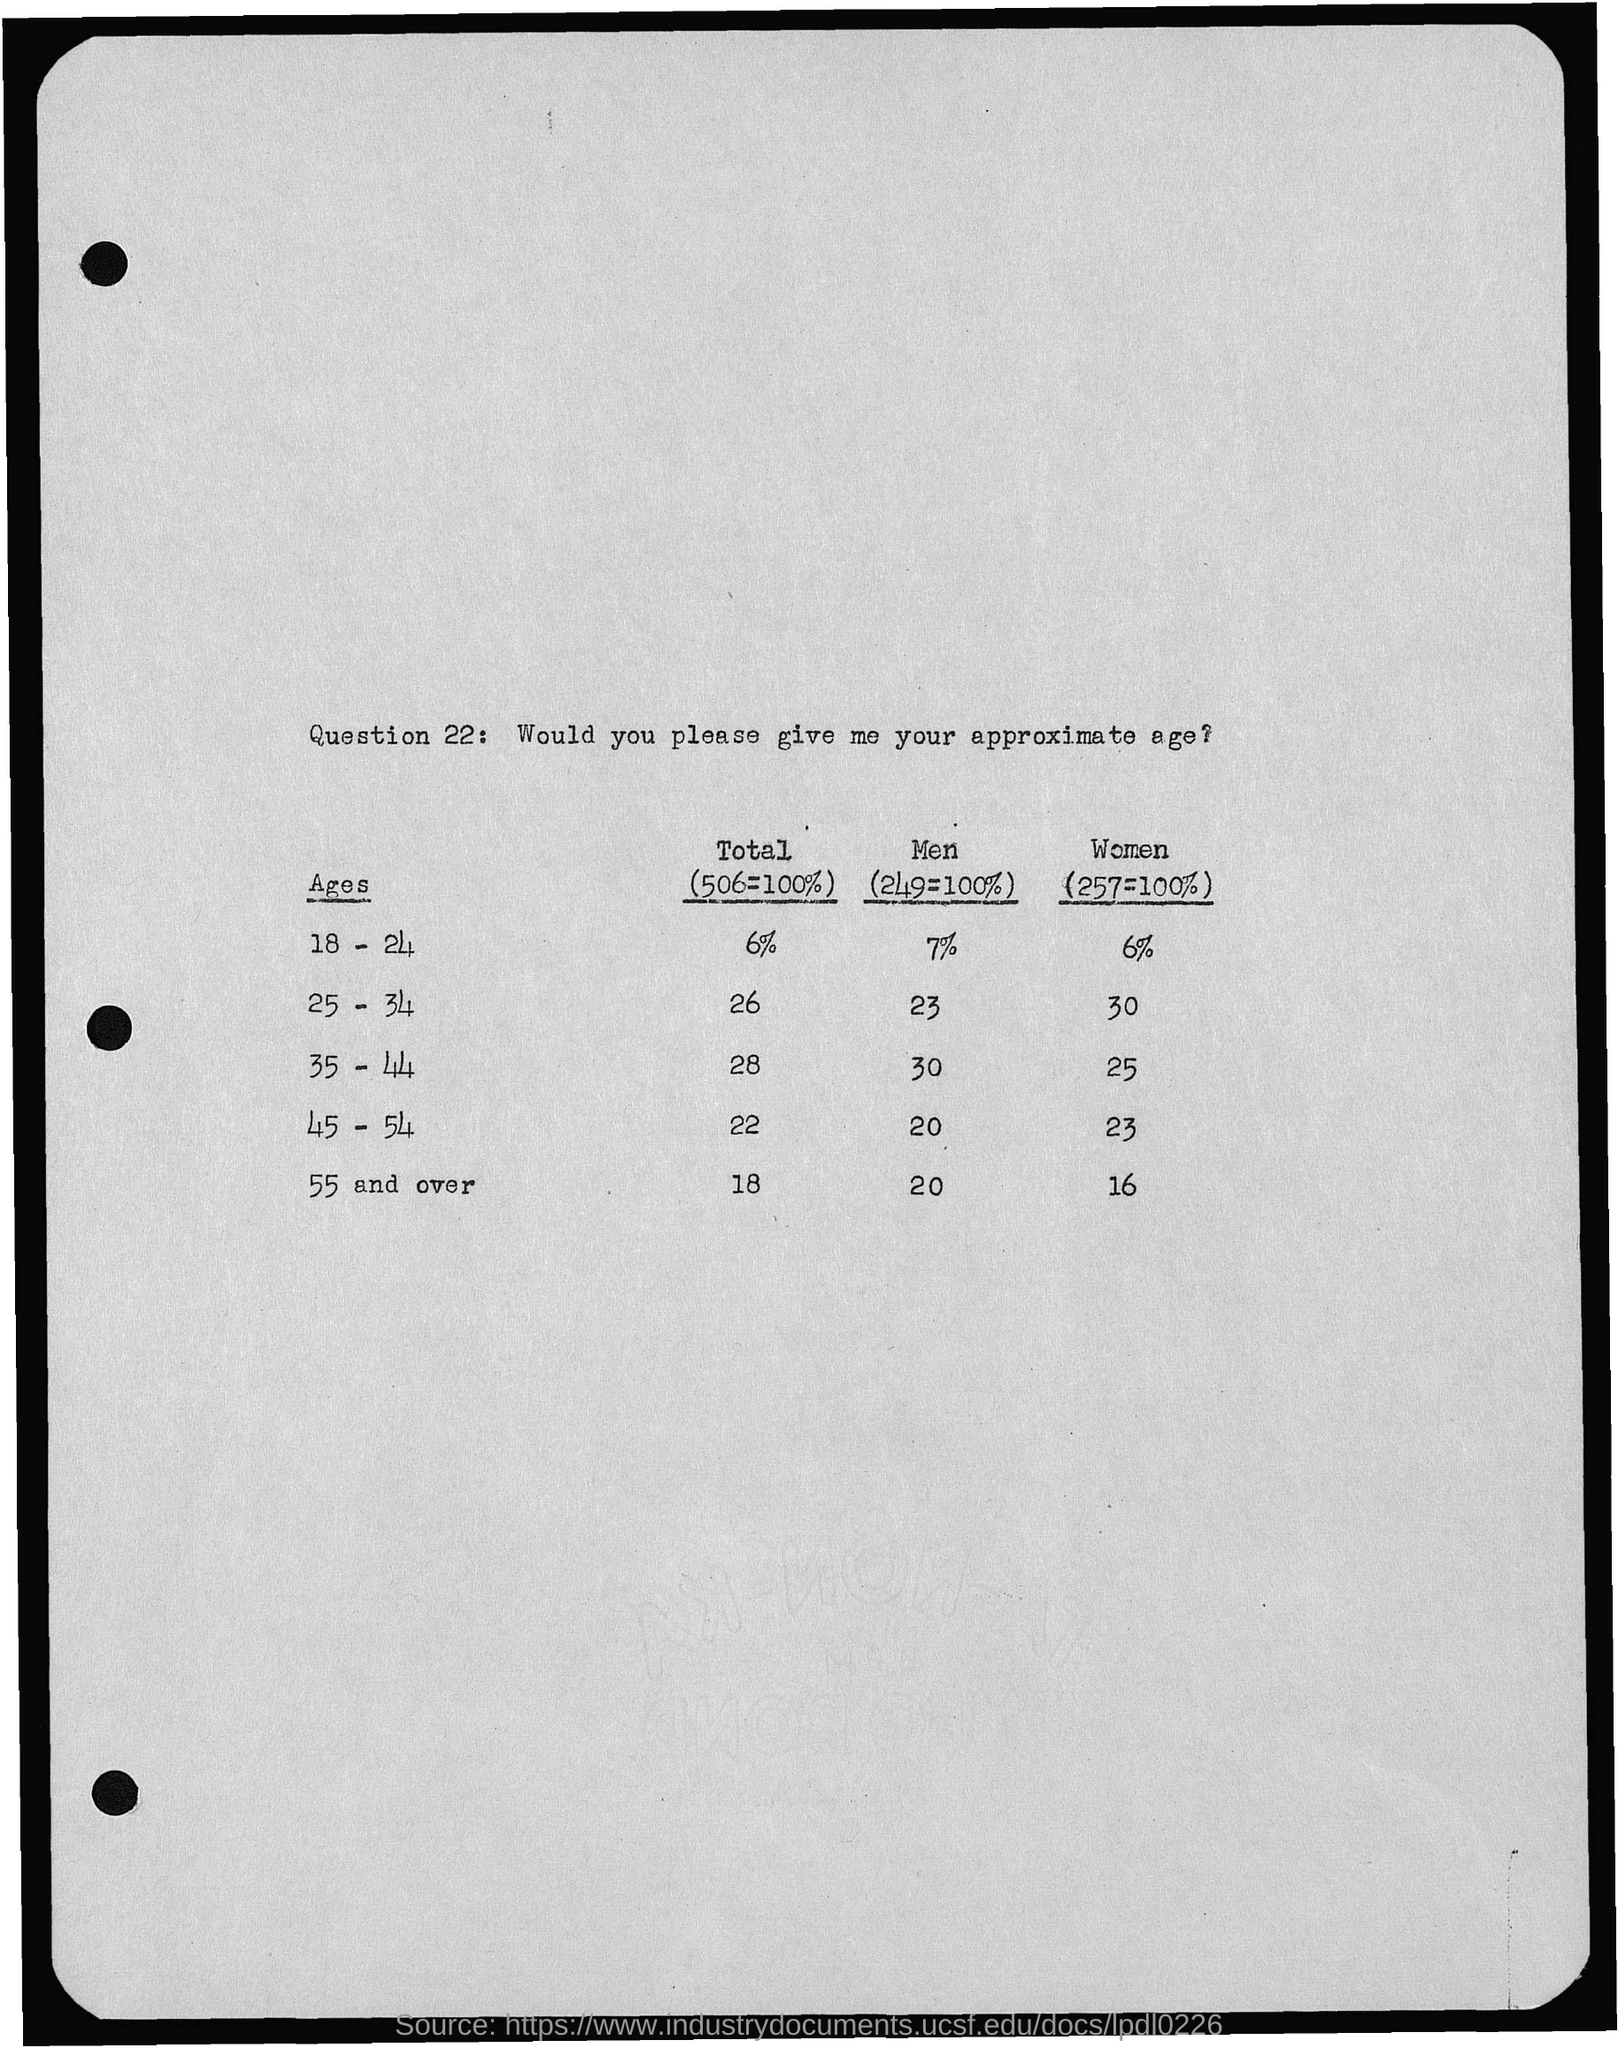What is the Total for ages 18 - 24?
Ensure brevity in your answer.  6%. What is the Total for ages 25 - 34?
Ensure brevity in your answer.  26. What is the Total for ages 35 - 44?
Ensure brevity in your answer.  28. What is the Total for ages 45 - 54?
Give a very brief answer. 22. 